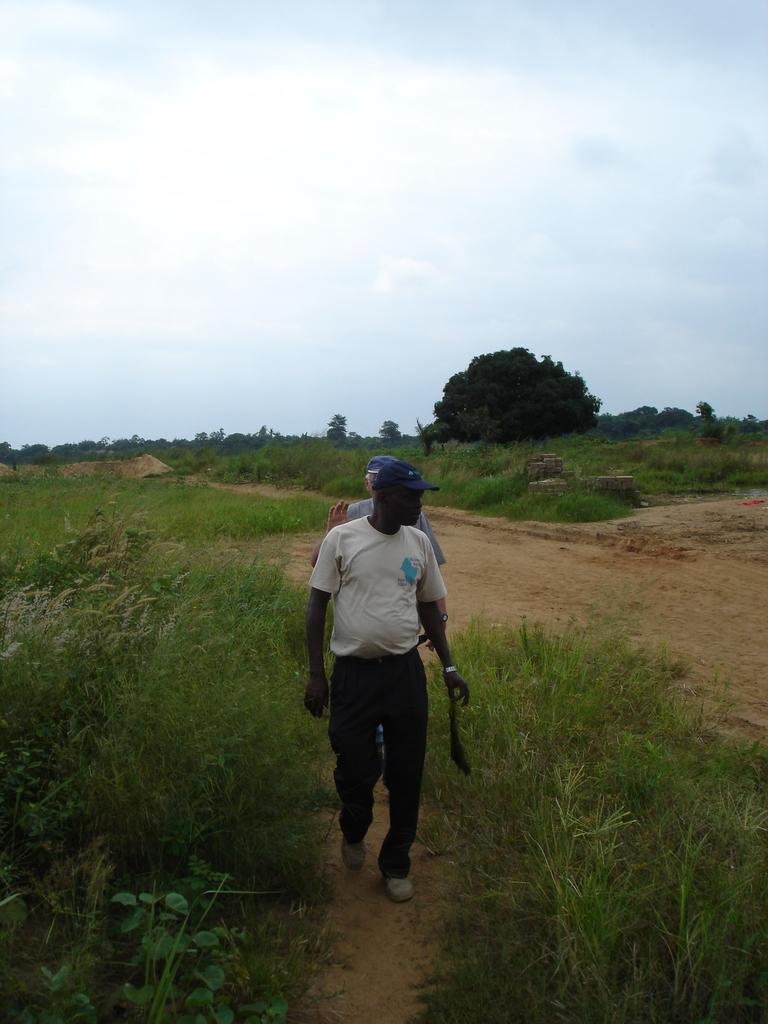In one or two sentences, can you explain what this image depicts? In this picture we can see two people on the path. We can see grass, plants, trees, other objects and the clouds in the sky. 